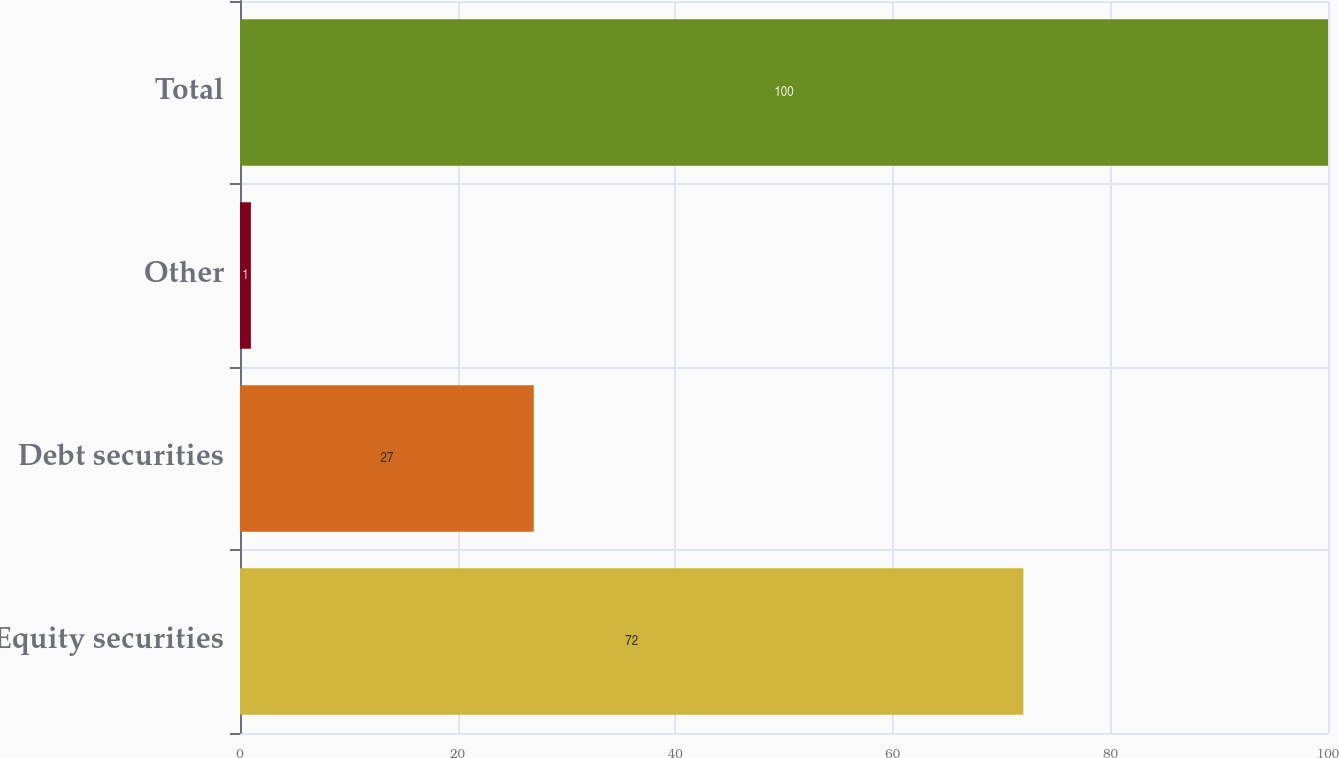Convert chart. <chart><loc_0><loc_0><loc_500><loc_500><bar_chart><fcel>Equity securities<fcel>Debt securities<fcel>Other<fcel>Total<nl><fcel>72<fcel>27<fcel>1<fcel>100<nl></chart> 